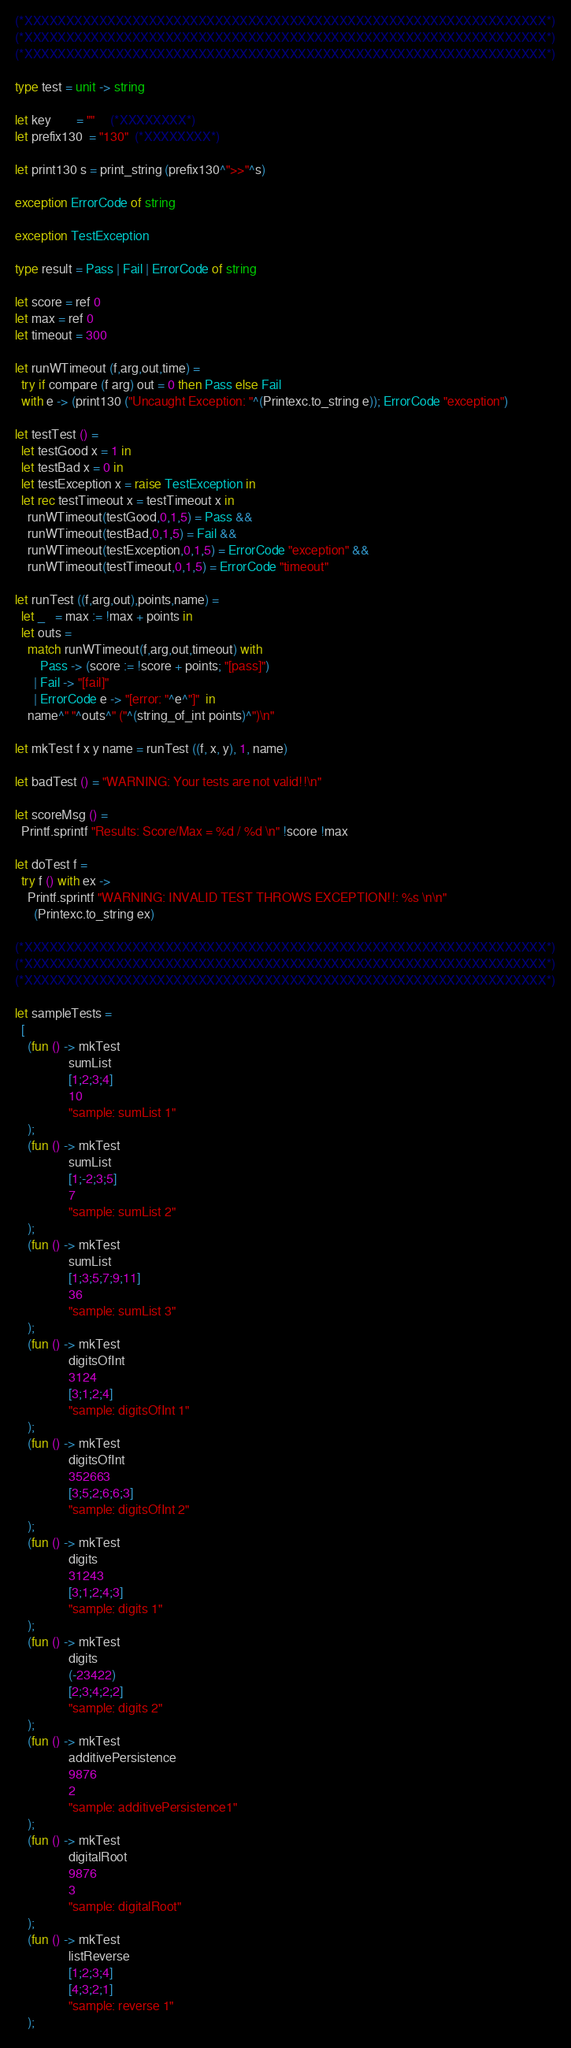<code> <loc_0><loc_0><loc_500><loc_500><_OCaml_>

(*XXXXXXXXXXXXXXXXXXXXXXXXXXXXXXXXXXXXXXXXXXXXXXXXXXXXXXXXXXXXXXX*)
(*XXXXXXXXXXXXXXXXXXXXXXXXXXXXXXXXXXXXXXXXXXXXXXXXXXXXXXXXXXXXXXX*)
(*XXXXXXXXXXXXXXXXXXXXXXXXXXXXXXXXXXXXXXXXXXXXXXXXXXXXXXXXXXXXXXX*)

type test = unit -> string

let key        = ""     (*XXXXXXXX*)
let prefix130  = "130"  (*XXXXXXXX*)

let print130 s = print_string (prefix130^">>"^s)

exception ErrorCode of string

exception TestException

type result = Pass | Fail | ErrorCode of string

let score = ref 0
let max = ref 0
let timeout = 300

let runWTimeout (f,arg,out,time) = 
  try if compare (f arg) out = 0 then Pass else Fail
  with e -> (print130 ("Uncaught Exception: "^(Printexc.to_string e)); ErrorCode "exception") 

let testTest () =
  let testGood x = 1 in
  let testBad x = 0 in 
  let testException x = raise TestException in
  let rec testTimeout x = testTimeout x in
    runWTimeout(testGood,0,1,5) = Pass &&  
    runWTimeout(testBad,0,1,5) = Fail &&  
    runWTimeout(testException,0,1,5) = ErrorCode "exception" && 
    runWTimeout(testTimeout,0,1,5) = ErrorCode "timeout"

let runTest ((f,arg,out),points,name) =
  let _   = max := !max + points in
  let outs = 
    match runWTimeout(f,arg,out,timeout) with 
        Pass -> (score := !score + points; "[pass]")
      | Fail -> "[fail]"
      | ErrorCode e -> "[error: "^e^"]"  in
    name^" "^outs^" ("^(string_of_int points)^")\n"

let mkTest f x y name = runTest ((f, x, y), 1, name)

let badTest () = "WARNING: Your tests are not valid!!\n"

let scoreMsg () = 
  Printf.sprintf "Results: Score/Max = %d / %d \n" !score !max 

let doTest f = 
  try f () with ex -> 
    Printf.sprintf "WARNING: INVALID TEST THROWS EXCEPTION!!: %s \n\n"
      (Printexc.to_string ex)

(*XXXXXXXXXXXXXXXXXXXXXXXXXXXXXXXXXXXXXXXXXXXXXXXXXXXXXXXXXXXXXXX*)
(*XXXXXXXXXXXXXXXXXXXXXXXXXXXXXXXXXXXXXXXXXXXXXXXXXXXXXXXXXXXXXXX*)
(*XXXXXXXXXXXXXXXXXXXXXXXXXXXXXXXXXXXXXXXXXXXXXXXXXXXXXXXXXXXXXXX*)

let sampleTests =
  [
    (fun () -> mkTest
                 sumList
                 [1;2;3;4]
                 10
                 "sample: sumList 1"
    );
    (fun () -> mkTest 
                 sumList 
                 [1;-2;3;5] 
                 7 
                 "sample: sumList 2"
    ); 
    (fun () -> mkTest 
                 sumList 
                 [1;3;5;7;9;11]
                 36 
                 "sample: sumList 3"
    ); 
    (fun () -> mkTest 
                 digitsOfInt 
                 3124 
                 [3;1;2;4] 
                 "sample: digitsOfInt 1"
    ); 
    (fun () -> mkTest 
                 digitsOfInt 
                 352663 
                 [3;5;2;6;6;3] 
                 "sample: digitsOfInt 2"
    ); 
    (fun () -> mkTest 
                 digits
                 31243
                 [3;1;2;4;3] 
                 "sample: digits 1"
    ); 
    (fun () -> mkTest 
                 digits
                 (-23422)
                 [2;3;4;2;2]
                 "sample: digits 2"
    ); 
    (fun () -> mkTest 
                 additivePersistence 
                 9876 
                 2 
                 "sample: additivePersistence1"
    ); 
    (fun () -> mkTest 
                 digitalRoot 
                 9876 
                 3 
                 "sample: digitalRoot"
    ); 
    (fun () -> mkTest 
                 listReverse
                 [1;2;3;4] 
                 [4;3;2;1]
                 "sample: reverse 1"
    ); </code> 